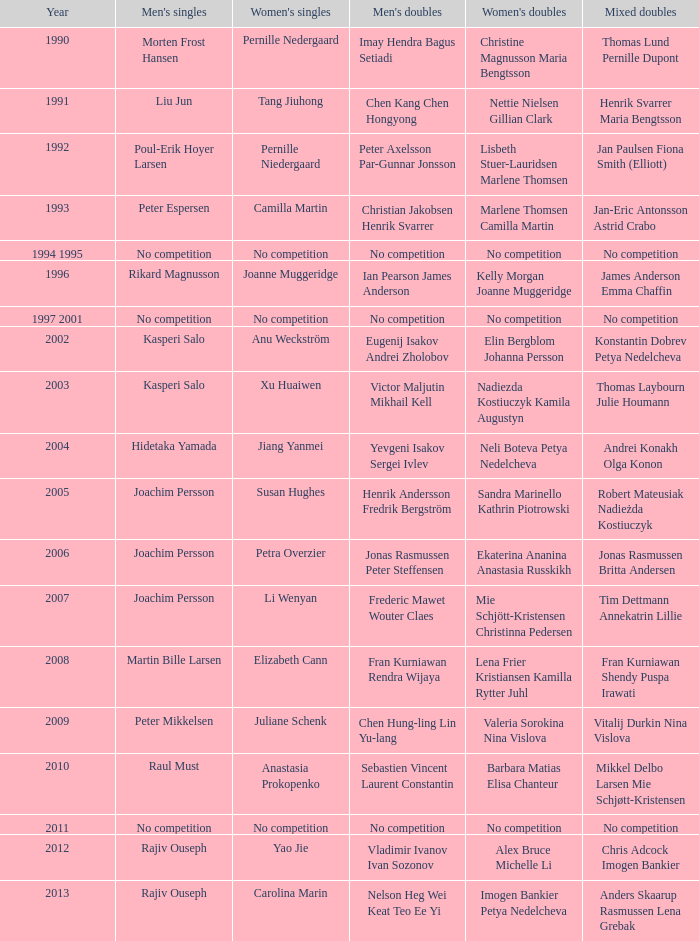Who claimed victory in the mixed doubles in 2007? Tim Dettmann Annekatrin Lillie. 